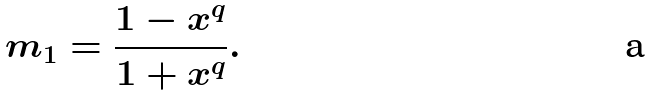<formula> <loc_0><loc_0><loc_500><loc_500>m _ { 1 } = \frac { 1 - x ^ { q } } { 1 + x ^ { q } } .</formula> 